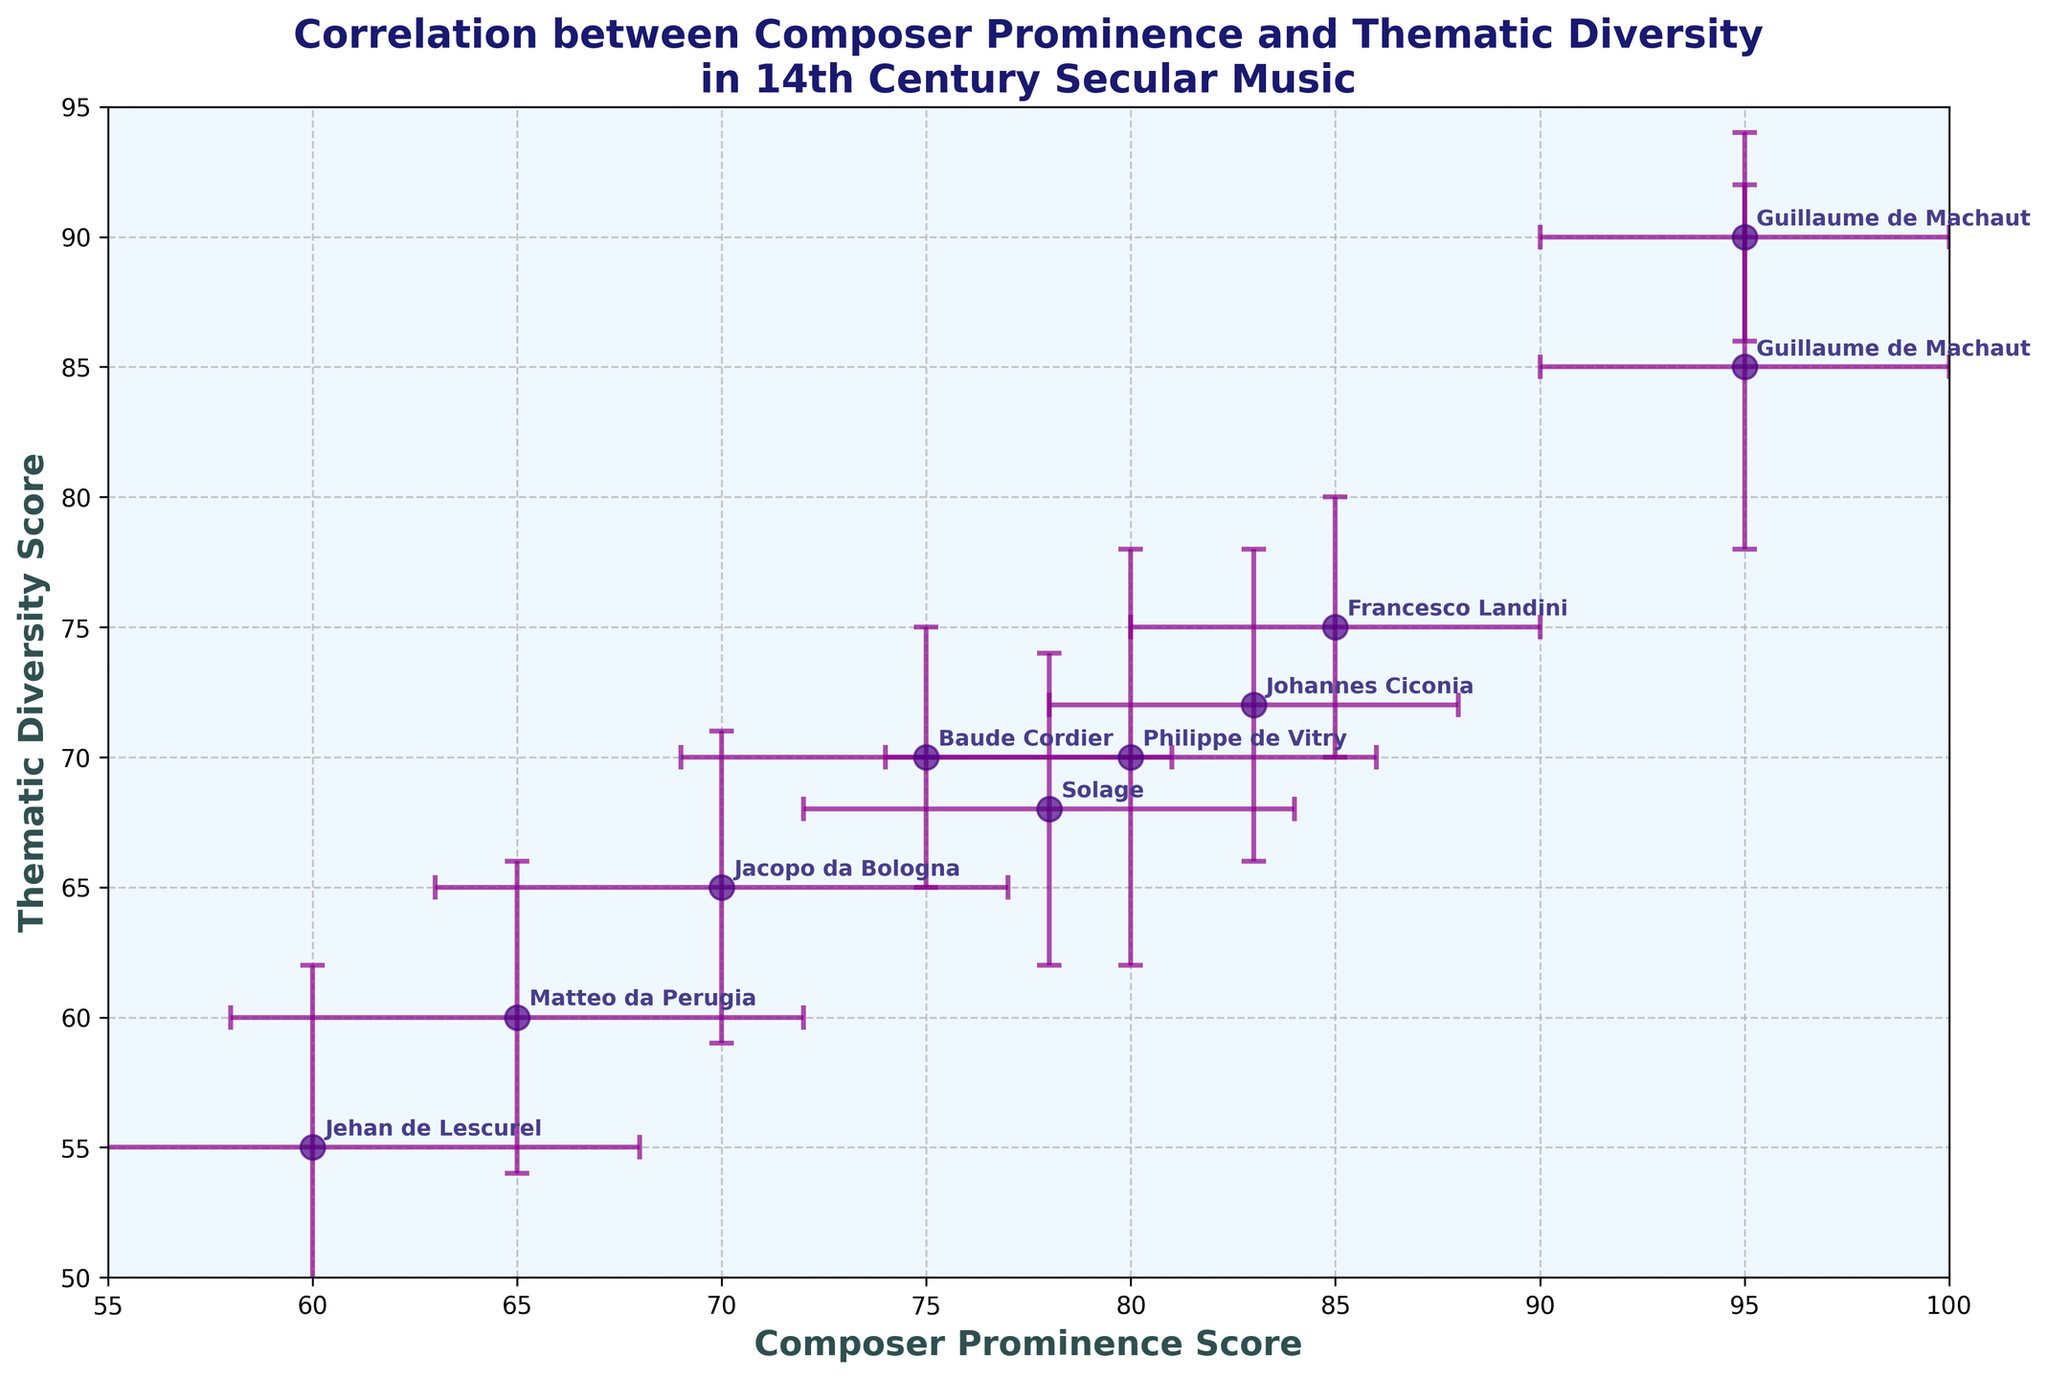What's the title of the figure? The title of the figure is displayed prominently at the top of the plot in bold and contains the main subject of the analysis.
Answer: Correlation between Composer Prominence and Thematic Diversity in 14th Century Secular Music How many data points are there? By counting the individual data points (scatter points) presented with error bars in the plot, we can determine the total number.
Answer: 9 Which composer has the highest Prominence Score? By examining the x-axis values where each composer is represented, we can find the highest Prominence Score.
Answer: Guillaume de Machaut For which composer is the thematic diversity highest? By looking at the y-axis where each composer's Thematic Diversity Score is plotted, we can identify the highest value.
Answer: Guillaume de Machaut What's the range of the Prominence Scores? The range is calculated by finding the difference between the maximum and minimum Prominence Scores plotted on the x-axis.
Answer: 35 Which two composers have the closest Thematic Diversity Scores? By comparing the y-axis values for each composer, we can determine which two have the smallest difference between their Thematic Diversity Scores.
Answer: Jacopo da Bologna and Baude Cordier What is the average Prominence Score of all composers? Sum up all the Prominence Scores and divide by the number of composers (9). (95 + 80 + 70 + 85 + 60 + 78 + 83 + 65 + 75) / 9 = 691 / 9 = 76.78
Answer: 76.78 Is there a positive correlation between Prominence Score and Thematic Diversity Score? A positive correlation would mean that as the Prominence Score increases, the Thematic Diversity Score also increases. By observing the general trend of the points and the slope direction, we can infer this.
Answer: Yes Which composer has the highest error in Prominence Score? By examining the horizontal error bars associated with each composer’s data point, the longest bar indicates the highest error in Prominence Score.
Answer: Jehan de Lescurel Are the enhancements to thematic diversity scores generally larger or smaller than the enhancements to prominence scores? By comparing the length of the error bars along the y-axis (Thematic Diversity Score) and the x-axis (Prominence Score), we can determine which errors are generally larger.
Answer: Larger 